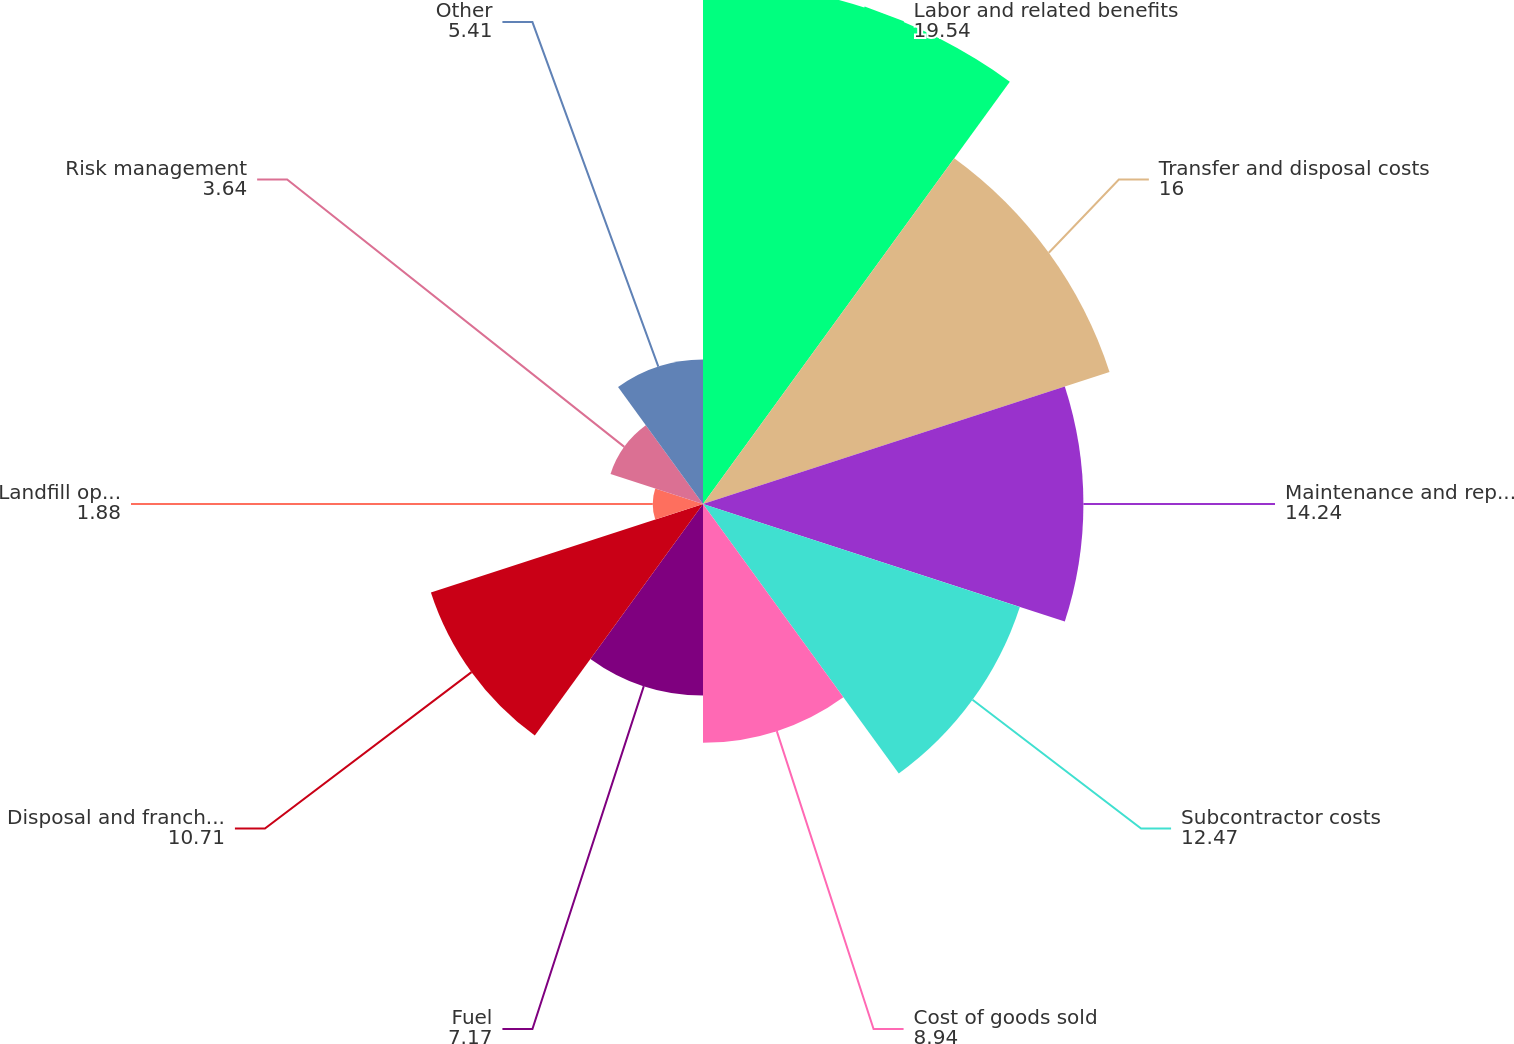Convert chart. <chart><loc_0><loc_0><loc_500><loc_500><pie_chart><fcel>Labor and related benefits<fcel>Transfer and disposal costs<fcel>Maintenance and repairs<fcel>Subcontractor costs<fcel>Cost of goods sold<fcel>Fuel<fcel>Disposal and franchise fees<fcel>Landfill operating costs<fcel>Risk management<fcel>Other<nl><fcel>19.54%<fcel>16.0%<fcel>14.24%<fcel>12.47%<fcel>8.94%<fcel>7.17%<fcel>10.71%<fcel>1.88%<fcel>3.64%<fcel>5.41%<nl></chart> 